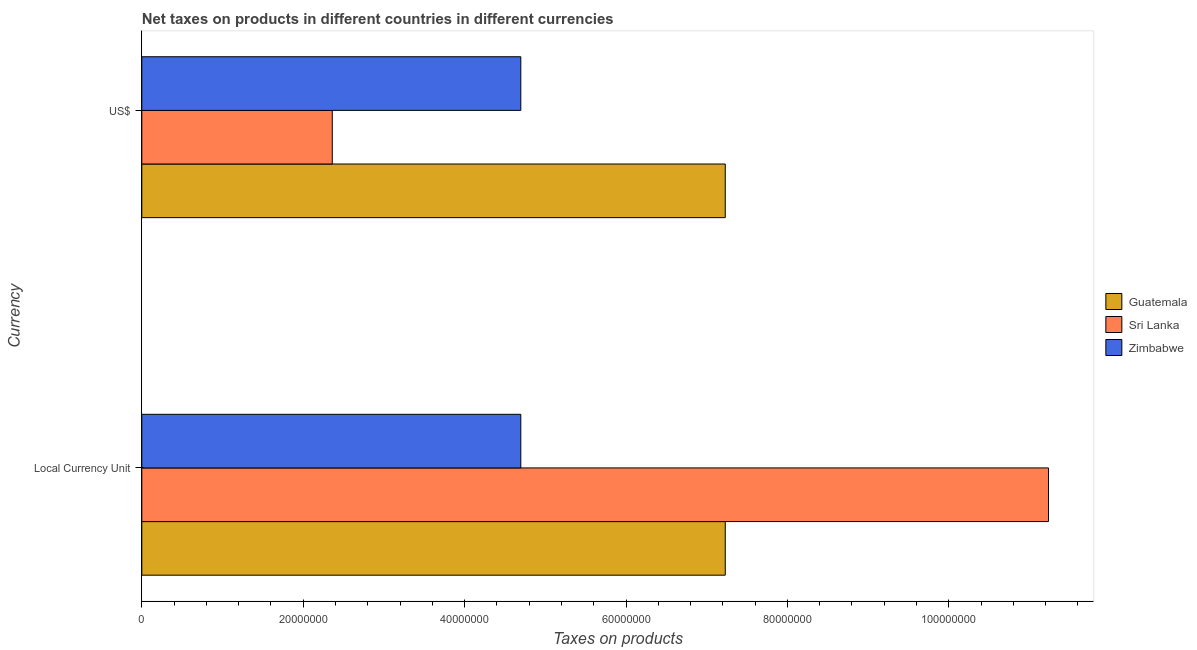How many groups of bars are there?
Your answer should be compact. 2. Are the number of bars per tick equal to the number of legend labels?
Provide a short and direct response. Yes. Are the number of bars on each tick of the Y-axis equal?
Your response must be concise. Yes. What is the label of the 1st group of bars from the top?
Keep it short and to the point. US$. What is the net taxes in constant 2005 us$ in Sri Lanka?
Your answer should be very brief. 1.12e+08. Across all countries, what is the maximum net taxes in us$?
Your response must be concise. 7.23e+07. Across all countries, what is the minimum net taxes in constant 2005 us$?
Your answer should be compact. 4.70e+07. In which country was the net taxes in constant 2005 us$ maximum?
Make the answer very short. Sri Lanka. In which country was the net taxes in us$ minimum?
Make the answer very short. Sri Lanka. What is the total net taxes in constant 2005 us$ in the graph?
Your response must be concise. 2.32e+08. What is the difference between the net taxes in us$ in Guatemala and that in Zimbabwe?
Make the answer very short. 2.53e+07. What is the difference between the net taxes in constant 2005 us$ in Zimbabwe and the net taxes in us$ in Sri Lanka?
Your answer should be compact. 2.34e+07. What is the average net taxes in us$ per country?
Your answer should be compact. 4.76e+07. What is the difference between the net taxes in us$ and net taxes in constant 2005 us$ in Guatemala?
Provide a succinct answer. 0. In how many countries, is the net taxes in us$ greater than 32000000 units?
Make the answer very short. 2. What is the ratio of the net taxes in constant 2005 us$ in Sri Lanka to that in Zimbabwe?
Offer a terse response. 2.39. Is the net taxes in us$ in Guatemala less than that in Sri Lanka?
Keep it short and to the point. No. In how many countries, is the net taxes in us$ greater than the average net taxes in us$ taken over all countries?
Provide a succinct answer. 1. What does the 1st bar from the top in Local Currency Unit represents?
Offer a very short reply. Zimbabwe. What does the 3rd bar from the bottom in US$ represents?
Offer a very short reply. Zimbabwe. How many bars are there?
Ensure brevity in your answer.  6. Are all the bars in the graph horizontal?
Make the answer very short. Yes. How many countries are there in the graph?
Keep it short and to the point. 3. What is the difference between two consecutive major ticks on the X-axis?
Offer a very short reply. 2.00e+07. Are the values on the major ticks of X-axis written in scientific E-notation?
Provide a short and direct response. No. Does the graph contain grids?
Your response must be concise. No. Where does the legend appear in the graph?
Your answer should be very brief. Center right. How many legend labels are there?
Your response must be concise. 3. What is the title of the graph?
Offer a terse response. Net taxes on products in different countries in different currencies. What is the label or title of the X-axis?
Make the answer very short. Taxes on products. What is the label or title of the Y-axis?
Your answer should be compact. Currency. What is the Taxes on products of Guatemala in Local Currency Unit?
Offer a very short reply. 7.23e+07. What is the Taxes on products of Sri Lanka in Local Currency Unit?
Offer a terse response. 1.12e+08. What is the Taxes on products in Zimbabwe in Local Currency Unit?
Give a very brief answer. 4.70e+07. What is the Taxes on products of Guatemala in US$?
Your response must be concise. 7.23e+07. What is the Taxes on products in Sri Lanka in US$?
Your answer should be compact. 2.36e+07. What is the Taxes on products of Zimbabwe in US$?
Ensure brevity in your answer.  4.70e+07. Across all Currency, what is the maximum Taxes on products in Guatemala?
Provide a short and direct response. 7.23e+07. Across all Currency, what is the maximum Taxes on products of Sri Lanka?
Your answer should be compact. 1.12e+08. Across all Currency, what is the maximum Taxes on products in Zimbabwe?
Your answer should be compact. 4.70e+07. Across all Currency, what is the minimum Taxes on products of Guatemala?
Give a very brief answer. 7.23e+07. Across all Currency, what is the minimum Taxes on products of Sri Lanka?
Provide a short and direct response. 2.36e+07. Across all Currency, what is the minimum Taxes on products of Zimbabwe?
Your answer should be compact. 4.70e+07. What is the total Taxes on products of Guatemala in the graph?
Offer a very short reply. 1.45e+08. What is the total Taxes on products in Sri Lanka in the graph?
Provide a succinct answer. 1.36e+08. What is the total Taxes on products in Zimbabwe in the graph?
Your answer should be very brief. 9.39e+07. What is the difference between the Taxes on products in Sri Lanka in Local Currency Unit and that in US$?
Your response must be concise. 8.88e+07. What is the difference between the Taxes on products in Zimbabwe in Local Currency Unit and that in US$?
Offer a terse response. 0. What is the difference between the Taxes on products in Guatemala in Local Currency Unit and the Taxes on products in Sri Lanka in US$?
Give a very brief answer. 4.87e+07. What is the difference between the Taxes on products of Guatemala in Local Currency Unit and the Taxes on products of Zimbabwe in US$?
Your answer should be very brief. 2.53e+07. What is the difference between the Taxes on products in Sri Lanka in Local Currency Unit and the Taxes on products in Zimbabwe in US$?
Ensure brevity in your answer.  6.54e+07. What is the average Taxes on products in Guatemala per Currency?
Ensure brevity in your answer.  7.23e+07. What is the average Taxes on products of Sri Lanka per Currency?
Offer a terse response. 6.80e+07. What is the average Taxes on products of Zimbabwe per Currency?
Provide a short and direct response. 4.70e+07. What is the difference between the Taxes on products in Guatemala and Taxes on products in Sri Lanka in Local Currency Unit?
Ensure brevity in your answer.  -4.01e+07. What is the difference between the Taxes on products in Guatemala and Taxes on products in Zimbabwe in Local Currency Unit?
Provide a succinct answer. 2.53e+07. What is the difference between the Taxes on products in Sri Lanka and Taxes on products in Zimbabwe in Local Currency Unit?
Your answer should be compact. 6.54e+07. What is the difference between the Taxes on products in Guatemala and Taxes on products in Sri Lanka in US$?
Keep it short and to the point. 4.87e+07. What is the difference between the Taxes on products in Guatemala and Taxes on products in Zimbabwe in US$?
Your response must be concise. 2.53e+07. What is the difference between the Taxes on products in Sri Lanka and Taxes on products in Zimbabwe in US$?
Keep it short and to the point. -2.34e+07. What is the ratio of the Taxes on products of Guatemala in Local Currency Unit to that in US$?
Your answer should be compact. 1. What is the ratio of the Taxes on products in Sri Lanka in Local Currency Unit to that in US$?
Offer a terse response. 4.76. What is the difference between the highest and the second highest Taxes on products of Guatemala?
Give a very brief answer. 0. What is the difference between the highest and the second highest Taxes on products of Sri Lanka?
Your response must be concise. 8.88e+07. What is the difference between the highest and the lowest Taxes on products of Guatemala?
Keep it short and to the point. 0. What is the difference between the highest and the lowest Taxes on products of Sri Lanka?
Offer a terse response. 8.88e+07. What is the difference between the highest and the lowest Taxes on products in Zimbabwe?
Your response must be concise. 0. 